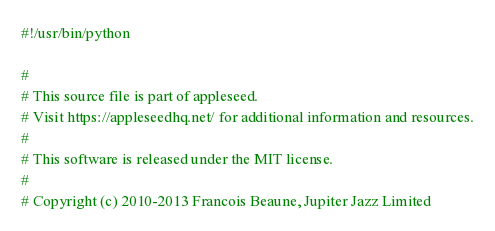Convert code to text. <code><loc_0><loc_0><loc_500><loc_500><_Python_>#!/usr/bin/python

#
# This source file is part of appleseed.
# Visit https://appleseedhq.net/ for additional information and resources.
#
# This software is released under the MIT license.
#
# Copyright (c) 2010-2013 Francois Beaune, Jupiter Jazz Limited</code> 